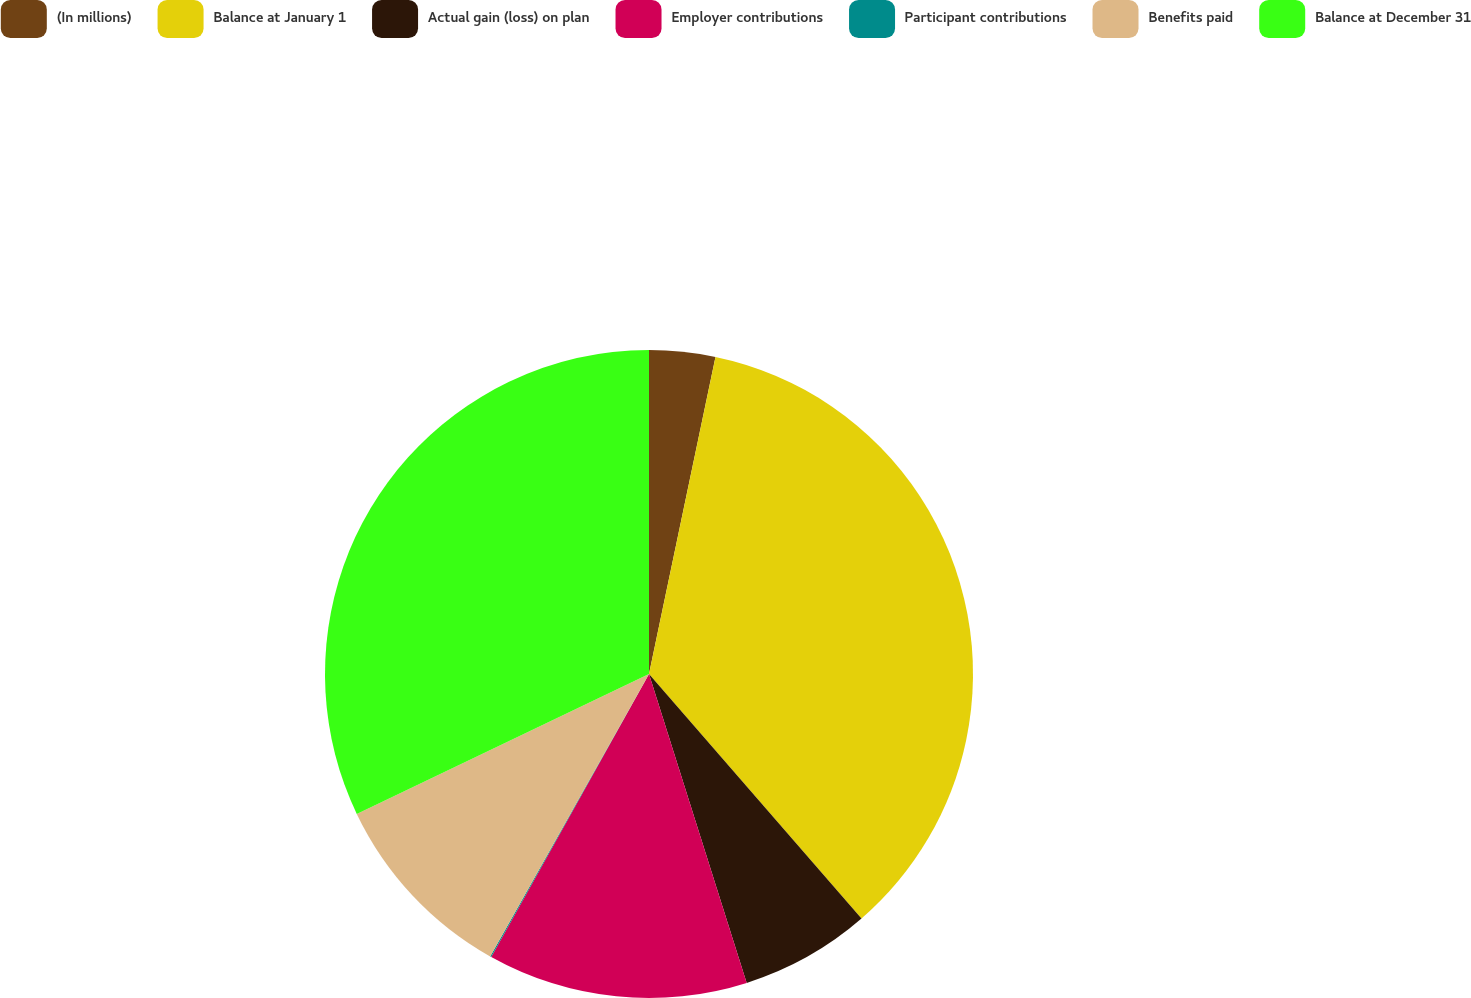Convert chart to OTSL. <chart><loc_0><loc_0><loc_500><loc_500><pie_chart><fcel>(In millions)<fcel>Balance at January 1<fcel>Actual gain (loss) on plan<fcel>Employer contributions<fcel>Participant contributions<fcel>Benefits paid<fcel>Balance at December 31<nl><fcel>3.29%<fcel>35.33%<fcel>6.51%<fcel>12.97%<fcel>0.06%<fcel>9.74%<fcel>32.11%<nl></chart> 